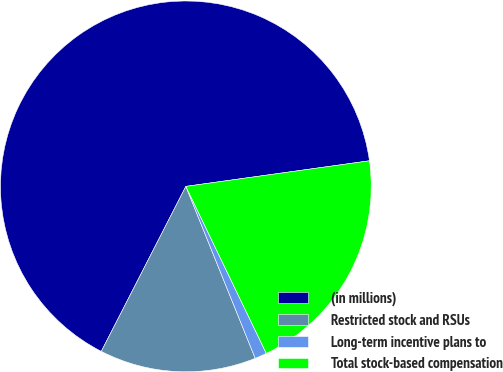Convert chart to OTSL. <chart><loc_0><loc_0><loc_500><loc_500><pie_chart><fcel>(in millions)<fcel>Restricted stock and RSUs<fcel>Long-term incentive plans to<fcel>Total stock-based compensation<nl><fcel>65.26%<fcel>13.64%<fcel>1.04%<fcel>20.06%<nl></chart> 